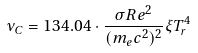Convert formula to latex. <formula><loc_0><loc_0><loc_500><loc_500>\nu _ { C } = 1 3 4 . 0 4 \cdot \frac { \sigma R e ^ { 2 } } { ( m _ { e } c ^ { 2 } ) ^ { 2 } } \xi T ^ { 4 } _ { r }</formula> 